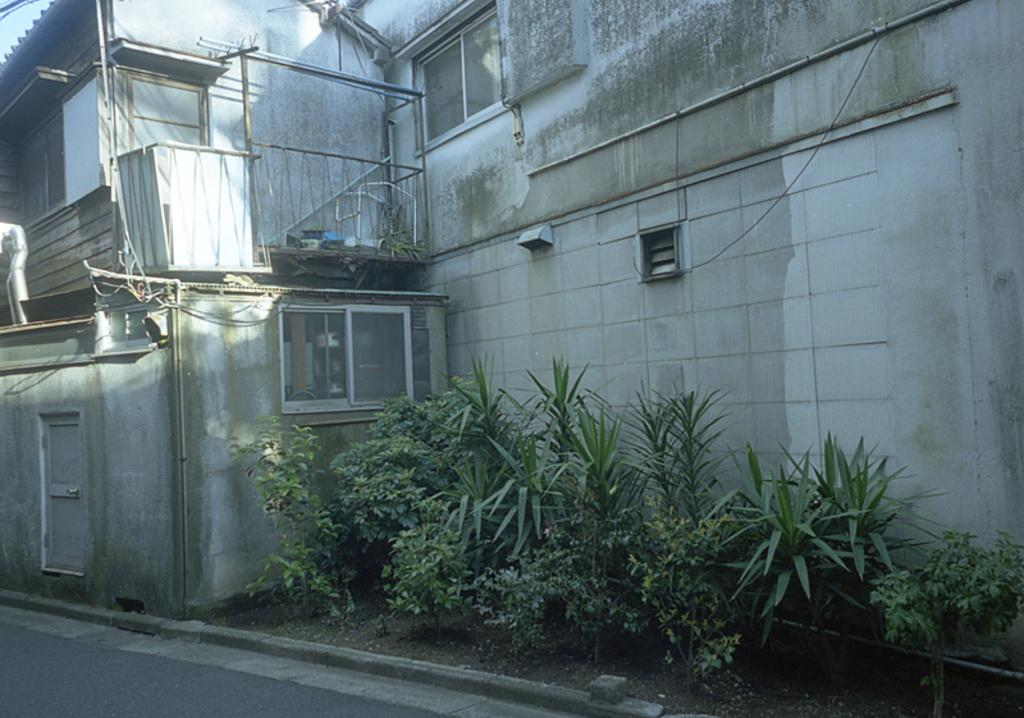What is the main structure in the center of the image? There is a building in the center of the image. What can be seen at the bottom of the image? There are plants and a road at the bottom of the image. How many ants can be seen carrying seeds near the heart-shaped plant in the image? There are no ants, seeds, or heart-shaped plants present in the image. 